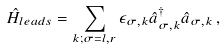Convert formula to latex. <formula><loc_0><loc_0><loc_500><loc_500>\hat { H } _ { l e a d s } = \sum _ { k ; \sigma = l , r } \epsilon _ { \sigma , k } \hat { a } ^ { \dagger } _ { \sigma , k } \hat { a } _ { \sigma , k } \, ,</formula> 